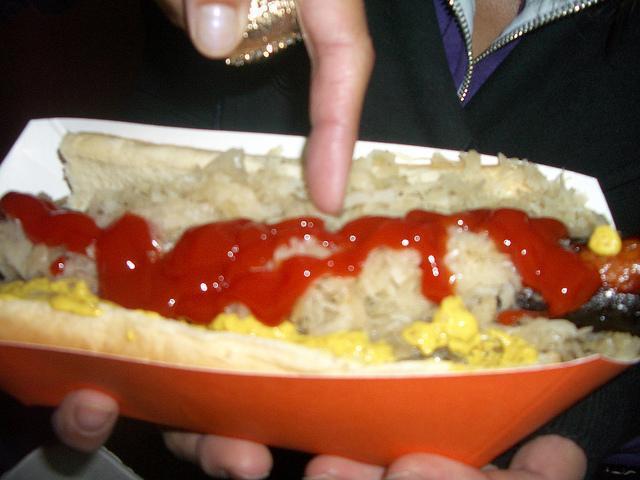How many people are visible?
Give a very brief answer. 2. How many cows are in the background?
Give a very brief answer. 0. 